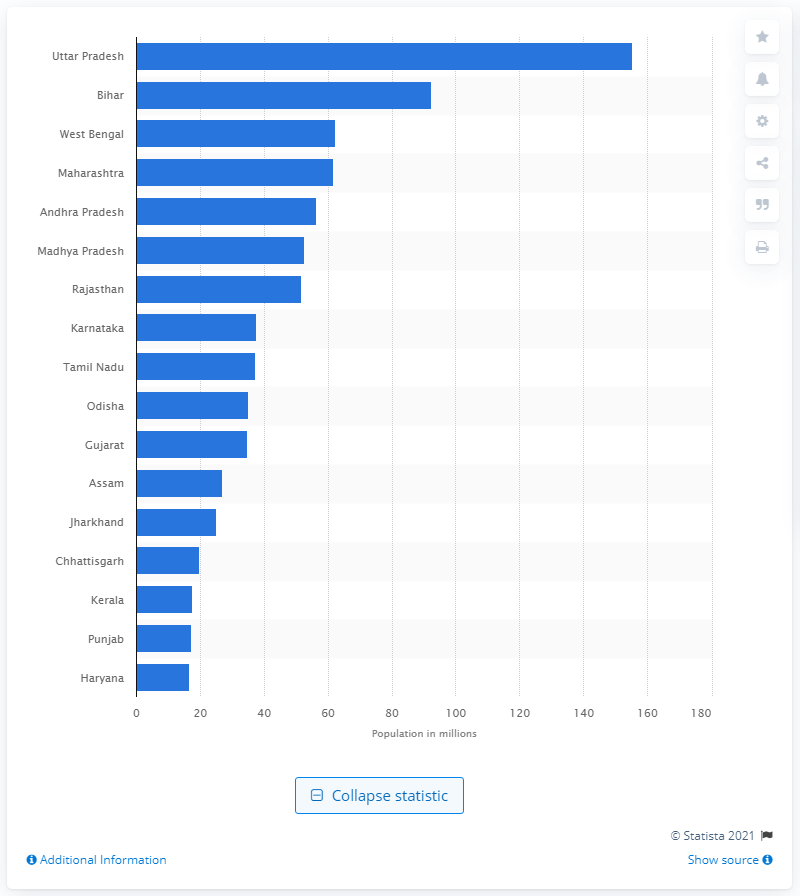List a handful of essential elements in this visual. In 2011, it is estimated that approximately 92,341 people lived in rural areas. Uttar Pradesh had the highest number of rural inhabitants in India in 2011. 